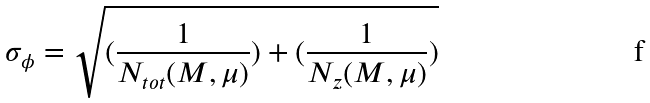Convert formula to latex. <formula><loc_0><loc_0><loc_500><loc_500>\sigma _ { \phi } = \sqrt { ( \frac { 1 } { N _ { t o t } ( M , \mu ) } ) + ( \frac { 1 } { N _ { z } ( M , \mu ) } ) }</formula> 